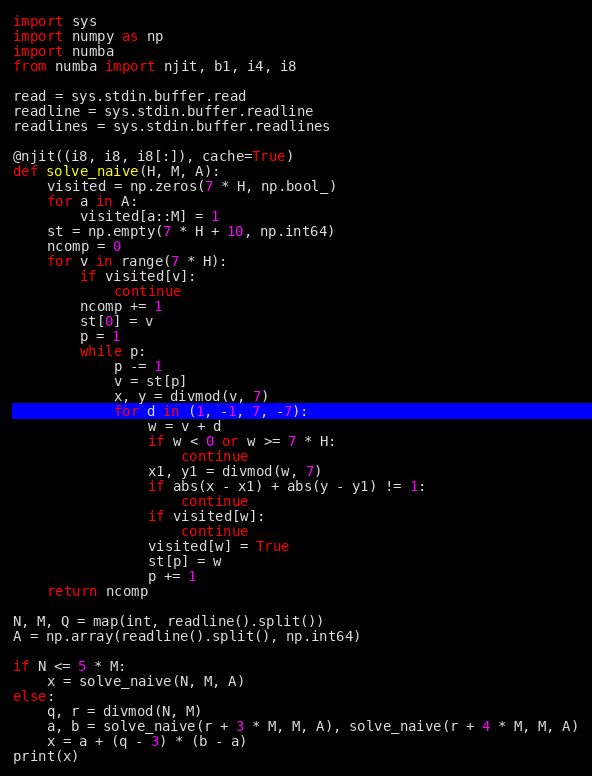Convert code to text. <code><loc_0><loc_0><loc_500><loc_500><_Python_>import sys
import numpy as np
import numba
from numba import njit, b1, i4, i8

read = sys.stdin.buffer.read
readline = sys.stdin.buffer.readline
readlines = sys.stdin.buffer.readlines

@njit((i8, i8, i8[:]), cache=True)
def solve_naive(H, M, A):
    visited = np.zeros(7 * H, np.bool_)
    for a in A:
        visited[a::M] = 1
    st = np.empty(7 * H + 10, np.int64)
    ncomp = 0
    for v in range(7 * H):
        if visited[v]:
            continue
        ncomp += 1
        st[0] = v
        p = 1
        while p:
            p -= 1
            v = st[p]
            x, y = divmod(v, 7)
            for d in (1, -1, 7, -7):
                w = v + d
                if w < 0 or w >= 7 * H:
                    continue
                x1, y1 = divmod(w, 7)
                if abs(x - x1) + abs(y - y1) != 1:
                    continue
                if visited[w]:
                    continue
                visited[w] = True
                st[p] = w
                p += 1
    return ncomp

N, M, Q = map(int, readline().split())
A = np.array(readline().split(), np.int64)

if N <= 5 * M:
    x = solve_naive(N, M, A)
else:
    q, r = divmod(N, M)
    a, b = solve_naive(r + 3 * M, M, A), solve_naive(r + 4 * M, M, A)
    x = a + (q - 3) * (b - a)
print(x)</code> 